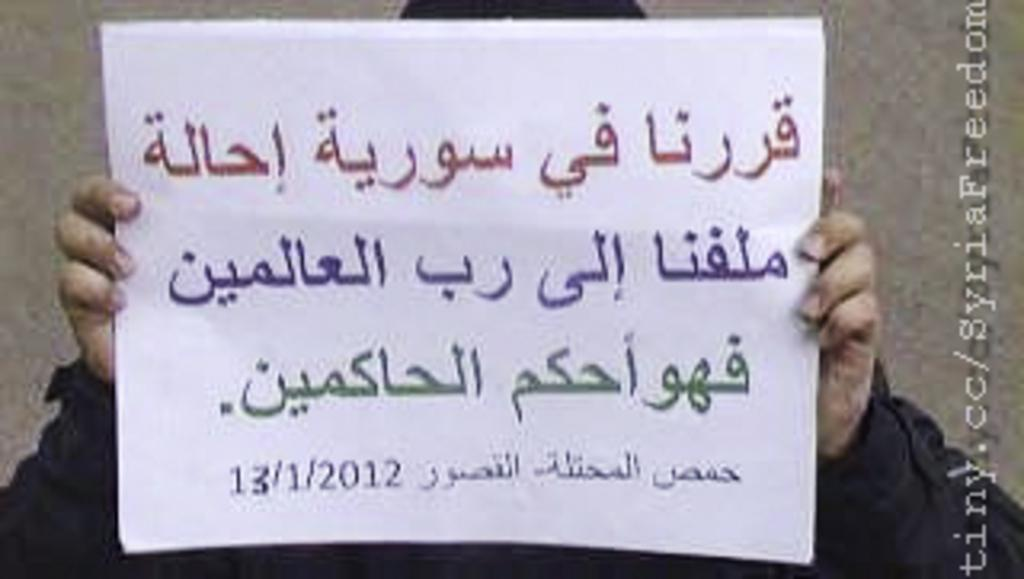<image>
Relay a brief, clear account of the picture shown. a man holding a note in a foreign language dated 13/1/2012 